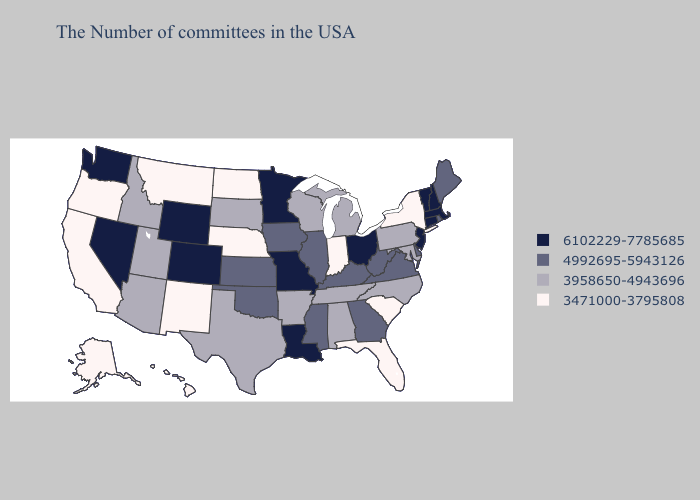Does Wisconsin have the lowest value in the USA?
Quick response, please. No. Does Maine have the lowest value in the USA?
Short answer required. No. Name the states that have a value in the range 6102229-7785685?
Be succinct. Massachusetts, New Hampshire, Vermont, Connecticut, New Jersey, Ohio, Louisiana, Missouri, Minnesota, Wyoming, Colorado, Nevada, Washington. What is the highest value in the USA?
Keep it brief. 6102229-7785685. What is the value of Maine?
Quick response, please. 4992695-5943126. What is the value of Connecticut?
Keep it brief. 6102229-7785685. What is the value of Alabama?
Write a very short answer. 3958650-4943696. Name the states that have a value in the range 6102229-7785685?
Be succinct. Massachusetts, New Hampshire, Vermont, Connecticut, New Jersey, Ohio, Louisiana, Missouri, Minnesota, Wyoming, Colorado, Nevada, Washington. Among the states that border Utah , does Arizona have the lowest value?
Keep it brief. No. Name the states that have a value in the range 6102229-7785685?
Concise answer only. Massachusetts, New Hampshire, Vermont, Connecticut, New Jersey, Ohio, Louisiana, Missouri, Minnesota, Wyoming, Colorado, Nevada, Washington. What is the lowest value in the USA?
Write a very short answer. 3471000-3795808. What is the value of Arkansas?
Write a very short answer. 3958650-4943696. Does the map have missing data?
Quick response, please. No. Does New Hampshire have the same value as Ohio?
Keep it brief. Yes. 